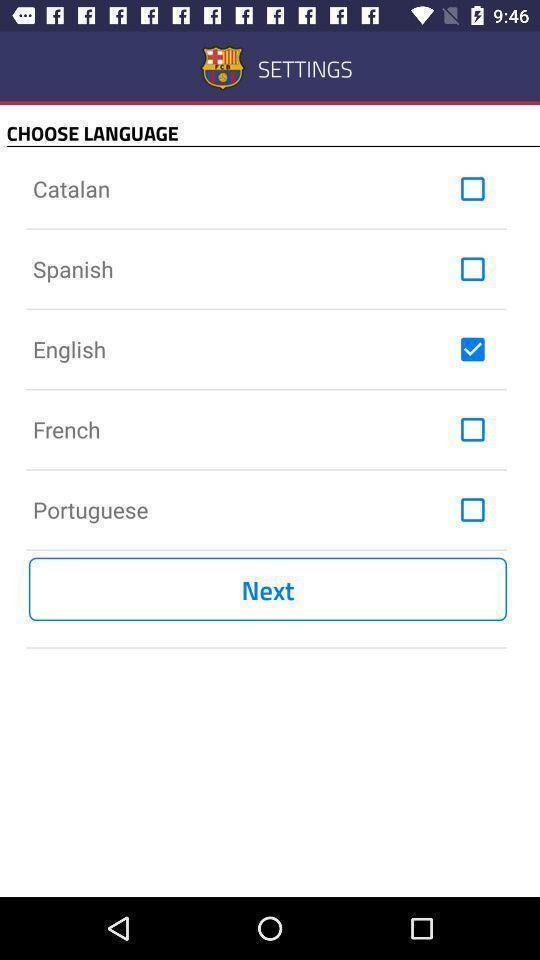Explain what's happening in this screen capture. Screen displaying the settings page. 